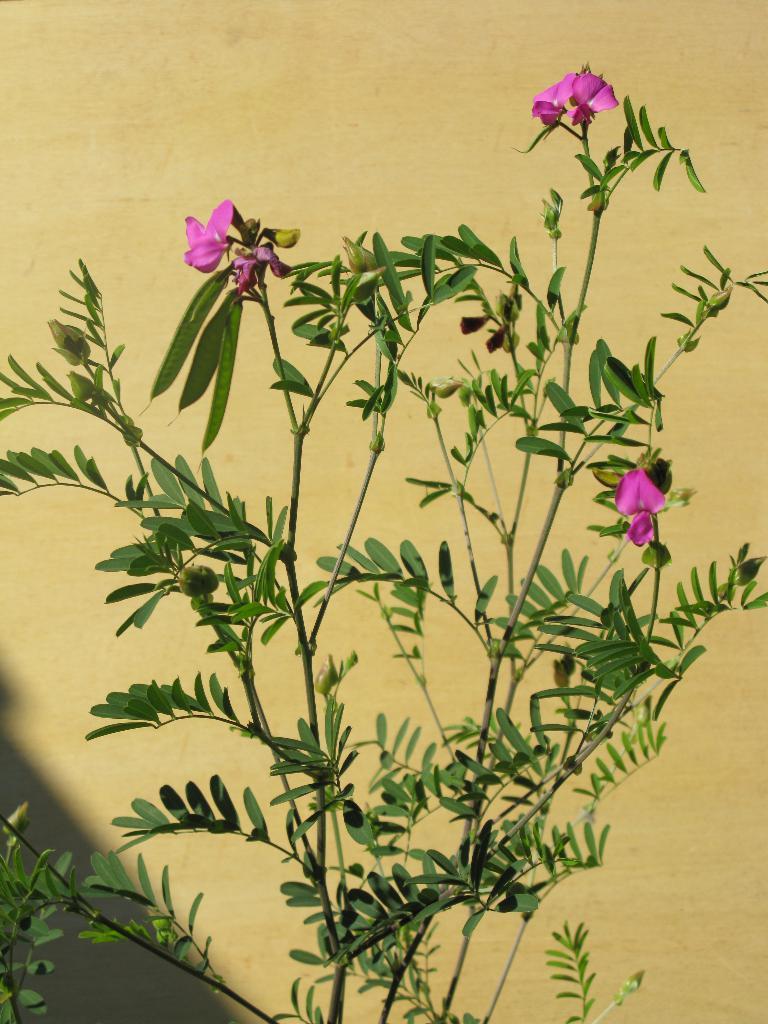Describe this image in one or two sentences. In this image I see a plant on which there are flowers which are of pink in color. In the background I see the wall which is of cream in color. 